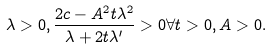Convert formula to latex. <formula><loc_0><loc_0><loc_500><loc_500>\lambda > 0 , \frac { 2 c - A ^ { 2 } t \lambda ^ { 2 } } { \lambda + 2 t \lambda ^ { \prime } } > 0 \forall t > 0 , A > 0 .</formula> 